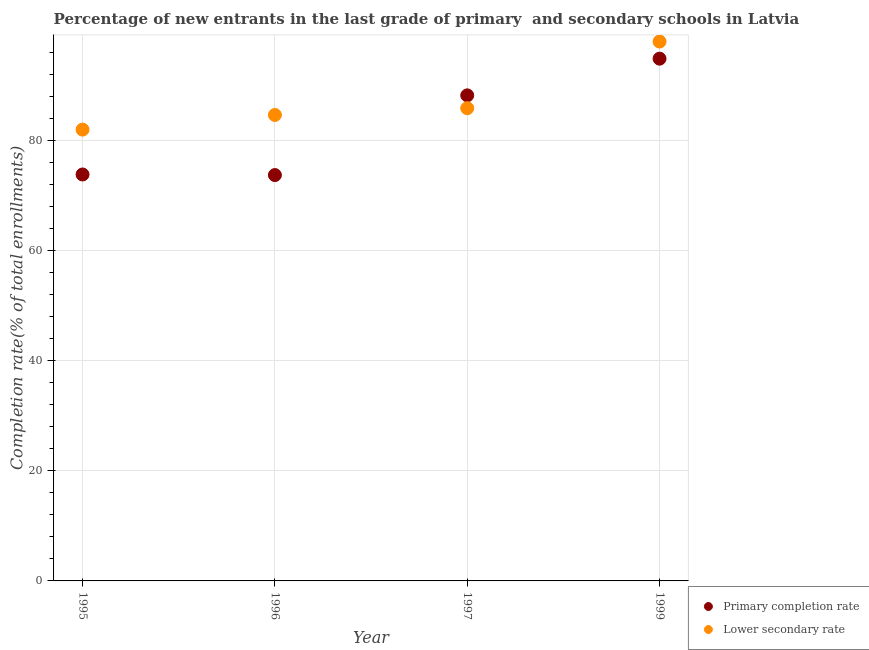How many different coloured dotlines are there?
Your answer should be very brief. 2. What is the completion rate in secondary schools in 1997?
Your answer should be compact. 85.88. Across all years, what is the maximum completion rate in secondary schools?
Keep it short and to the point. 97.99. Across all years, what is the minimum completion rate in secondary schools?
Your response must be concise. 82. In which year was the completion rate in primary schools minimum?
Your answer should be very brief. 1996. What is the total completion rate in primary schools in the graph?
Give a very brief answer. 330.67. What is the difference between the completion rate in secondary schools in 1997 and that in 1999?
Your response must be concise. -12.11. What is the difference between the completion rate in primary schools in 1996 and the completion rate in secondary schools in 1995?
Ensure brevity in your answer.  -8.26. What is the average completion rate in secondary schools per year?
Your response must be concise. 87.63. In the year 1996, what is the difference between the completion rate in primary schools and completion rate in secondary schools?
Provide a succinct answer. -10.92. What is the ratio of the completion rate in primary schools in 1995 to that in 1999?
Give a very brief answer. 0.78. What is the difference between the highest and the second highest completion rate in secondary schools?
Offer a very short reply. 12.11. What is the difference between the highest and the lowest completion rate in secondary schools?
Provide a short and direct response. 15.99. In how many years, is the completion rate in primary schools greater than the average completion rate in primary schools taken over all years?
Ensure brevity in your answer.  2. Is the completion rate in primary schools strictly less than the completion rate in secondary schools over the years?
Give a very brief answer. No. Are the values on the major ticks of Y-axis written in scientific E-notation?
Your response must be concise. No. Does the graph contain any zero values?
Keep it short and to the point. No. Does the graph contain grids?
Provide a succinct answer. Yes. Where does the legend appear in the graph?
Your response must be concise. Bottom right. How are the legend labels stacked?
Provide a short and direct response. Vertical. What is the title of the graph?
Your answer should be very brief. Percentage of new entrants in the last grade of primary  and secondary schools in Latvia. Does "Resident workers" appear as one of the legend labels in the graph?
Keep it short and to the point. No. What is the label or title of the X-axis?
Your answer should be compact. Year. What is the label or title of the Y-axis?
Your answer should be very brief. Completion rate(% of total enrollments). What is the Completion rate(% of total enrollments) in Primary completion rate in 1995?
Your answer should be very brief. 73.84. What is the Completion rate(% of total enrollments) in Lower secondary rate in 1995?
Ensure brevity in your answer.  82. What is the Completion rate(% of total enrollments) in Primary completion rate in 1996?
Make the answer very short. 73.73. What is the Completion rate(% of total enrollments) of Lower secondary rate in 1996?
Offer a terse response. 84.65. What is the Completion rate(% of total enrollments) in Primary completion rate in 1997?
Your answer should be very brief. 88.21. What is the Completion rate(% of total enrollments) in Lower secondary rate in 1997?
Provide a short and direct response. 85.88. What is the Completion rate(% of total enrollments) of Primary completion rate in 1999?
Keep it short and to the point. 94.88. What is the Completion rate(% of total enrollments) of Lower secondary rate in 1999?
Your answer should be compact. 97.99. Across all years, what is the maximum Completion rate(% of total enrollments) in Primary completion rate?
Provide a short and direct response. 94.88. Across all years, what is the maximum Completion rate(% of total enrollments) of Lower secondary rate?
Keep it short and to the point. 97.99. Across all years, what is the minimum Completion rate(% of total enrollments) in Primary completion rate?
Provide a short and direct response. 73.73. Across all years, what is the minimum Completion rate(% of total enrollments) in Lower secondary rate?
Offer a very short reply. 82. What is the total Completion rate(% of total enrollments) of Primary completion rate in the graph?
Ensure brevity in your answer.  330.67. What is the total Completion rate(% of total enrollments) in Lower secondary rate in the graph?
Offer a terse response. 350.52. What is the difference between the Completion rate(% of total enrollments) in Primary completion rate in 1995 and that in 1996?
Provide a short and direct response. 0.11. What is the difference between the Completion rate(% of total enrollments) in Lower secondary rate in 1995 and that in 1996?
Offer a terse response. -2.66. What is the difference between the Completion rate(% of total enrollments) of Primary completion rate in 1995 and that in 1997?
Your response must be concise. -14.37. What is the difference between the Completion rate(% of total enrollments) in Lower secondary rate in 1995 and that in 1997?
Offer a terse response. -3.89. What is the difference between the Completion rate(% of total enrollments) of Primary completion rate in 1995 and that in 1999?
Offer a very short reply. -21.04. What is the difference between the Completion rate(% of total enrollments) in Lower secondary rate in 1995 and that in 1999?
Offer a terse response. -15.99. What is the difference between the Completion rate(% of total enrollments) of Primary completion rate in 1996 and that in 1997?
Your answer should be very brief. -14.48. What is the difference between the Completion rate(% of total enrollments) in Lower secondary rate in 1996 and that in 1997?
Your answer should be compact. -1.23. What is the difference between the Completion rate(% of total enrollments) in Primary completion rate in 1996 and that in 1999?
Your answer should be compact. -21.14. What is the difference between the Completion rate(% of total enrollments) of Lower secondary rate in 1996 and that in 1999?
Your answer should be very brief. -13.34. What is the difference between the Completion rate(% of total enrollments) in Primary completion rate in 1997 and that in 1999?
Keep it short and to the point. -6.66. What is the difference between the Completion rate(% of total enrollments) of Lower secondary rate in 1997 and that in 1999?
Your answer should be compact. -12.11. What is the difference between the Completion rate(% of total enrollments) in Primary completion rate in 1995 and the Completion rate(% of total enrollments) in Lower secondary rate in 1996?
Ensure brevity in your answer.  -10.81. What is the difference between the Completion rate(% of total enrollments) in Primary completion rate in 1995 and the Completion rate(% of total enrollments) in Lower secondary rate in 1997?
Offer a very short reply. -12.04. What is the difference between the Completion rate(% of total enrollments) of Primary completion rate in 1995 and the Completion rate(% of total enrollments) of Lower secondary rate in 1999?
Your answer should be compact. -24.15. What is the difference between the Completion rate(% of total enrollments) in Primary completion rate in 1996 and the Completion rate(% of total enrollments) in Lower secondary rate in 1997?
Offer a very short reply. -12.15. What is the difference between the Completion rate(% of total enrollments) of Primary completion rate in 1996 and the Completion rate(% of total enrollments) of Lower secondary rate in 1999?
Give a very brief answer. -24.26. What is the difference between the Completion rate(% of total enrollments) in Primary completion rate in 1997 and the Completion rate(% of total enrollments) in Lower secondary rate in 1999?
Your response must be concise. -9.78. What is the average Completion rate(% of total enrollments) in Primary completion rate per year?
Keep it short and to the point. 82.67. What is the average Completion rate(% of total enrollments) of Lower secondary rate per year?
Give a very brief answer. 87.63. In the year 1995, what is the difference between the Completion rate(% of total enrollments) in Primary completion rate and Completion rate(% of total enrollments) in Lower secondary rate?
Provide a short and direct response. -8.16. In the year 1996, what is the difference between the Completion rate(% of total enrollments) of Primary completion rate and Completion rate(% of total enrollments) of Lower secondary rate?
Make the answer very short. -10.92. In the year 1997, what is the difference between the Completion rate(% of total enrollments) of Primary completion rate and Completion rate(% of total enrollments) of Lower secondary rate?
Your answer should be very brief. 2.33. In the year 1999, what is the difference between the Completion rate(% of total enrollments) in Primary completion rate and Completion rate(% of total enrollments) in Lower secondary rate?
Your response must be concise. -3.11. What is the ratio of the Completion rate(% of total enrollments) in Lower secondary rate in 1995 to that in 1996?
Keep it short and to the point. 0.97. What is the ratio of the Completion rate(% of total enrollments) of Primary completion rate in 1995 to that in 1997?
Your response must be concise. 0.84. What is the ratio of the Completion rate(% of total enrollments) of Lower secondary rate in 1995 to that in 1997?
Your response must be concise. 0.95. What is the ratio of the Completion rate(% of total enrollments) in Primary completion rate in 1995 to that in 1999?
Give a very brief answer. 0.78. What is the ratio of the Completion rate(% of total enrollments) of Lower secondary rate in 1995 to that in 1999?
Your response must be concise. 0.84. What is the ratio of the Completion rate(% of total enrollments) in Primary completion rate in 1996 to that in 1997?
Offer a very short reply. 0.84. What is the ratio of the Completion rate(% of total enrollments) of Lower secondary rate in 1996 to that in 1997?
Your answer should be compact. 0.99. What is the ratio of the Completion rate(% of total enrollments) in Primary completion rate in 1996 to that in 1999?
Provide a short and direct response. 0.78. What is the ratio of the Completion rate(% of total enrollments) of Lower secondary rate in 1996 to that in 1999?
Your answer should be very brief. 0.86. What is the ratio of the Completion rate(% of total enrollments) in Primary completion rate in 1997 to that in 1999?
Provide a short and direct response. 0.93. What is the ratio of the Completion rate(% of total enrollments) of Lower secondary rate in 1997 to that in 1999?
Give a very brief answer. 0.88. What is the difference between the highest and the second highest Completion rate(% of total enrollments) of Primary completion rate?
Make the answer very short. 6.66. What is the difference between the highest and the second highest Completion rate(% of total enrollments) in Lower secondary rate?
Your answer should be compact. 12.11. What is the difference between the highest and the lowest Completion rate(% of total enrollments) of Primary completion rate?
Your response must be concise. 21.14. What is the difference between the highest and the lowest Completion rate(% of total enrollments) in Lower secondary rate?
Provide a succinct answer. 15.99. 